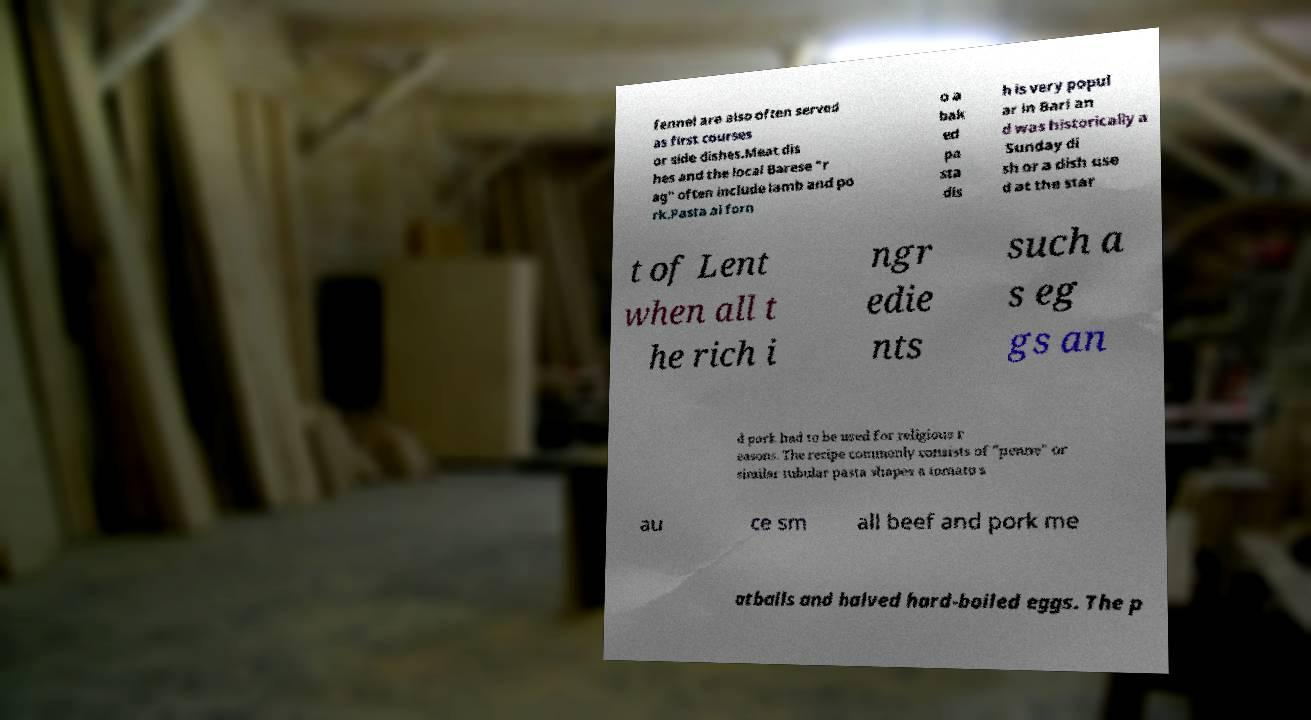Please identify and transcribe the text found in this image. fennel are also often served as first courses or side dishes.Meat dis hes and the local Barese "r ag" often include lamb and po rk.Pasta al forn o a bak ed pa sta dis h is very popul ar in Bari an d was historically a Sunday di sh or a dish use d at the star t of Lent when all t he rich i ngr edie nts such a s eg gs an d pork had to be used for religious r easons. The recipe commonly consists of "penne" or similar tubular pasta shapes a tomato s au ce sm all beef and pork me atballs and halved hard-boiled eggs. The p 